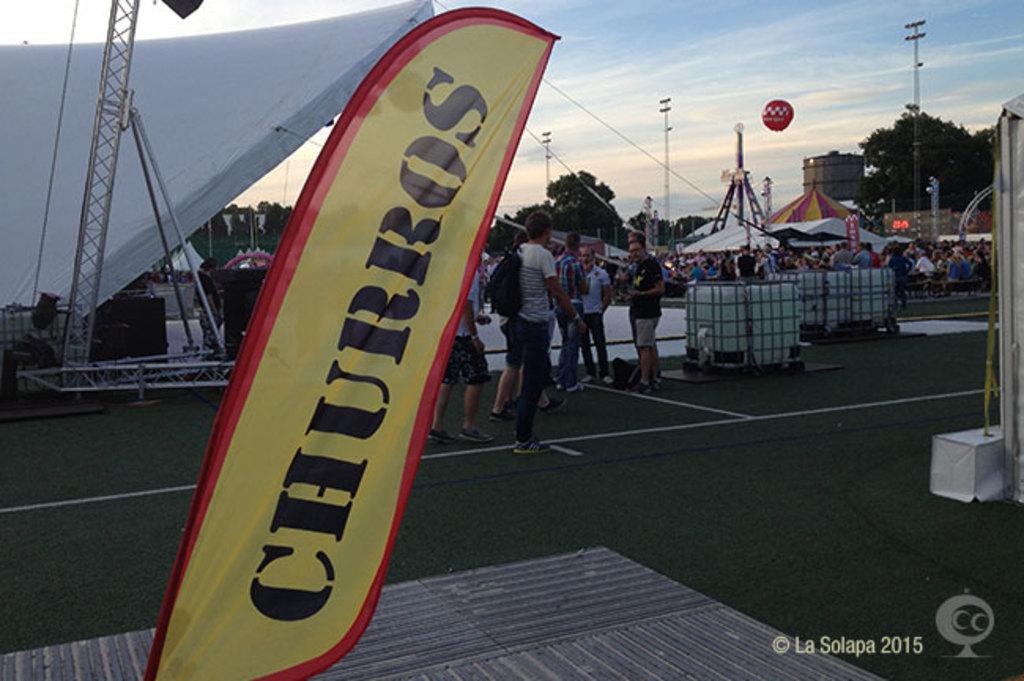What does the banner say?
Give a very brief answer. Churros. What year was this photo taken?
Keep it short and to the point. 2015. 